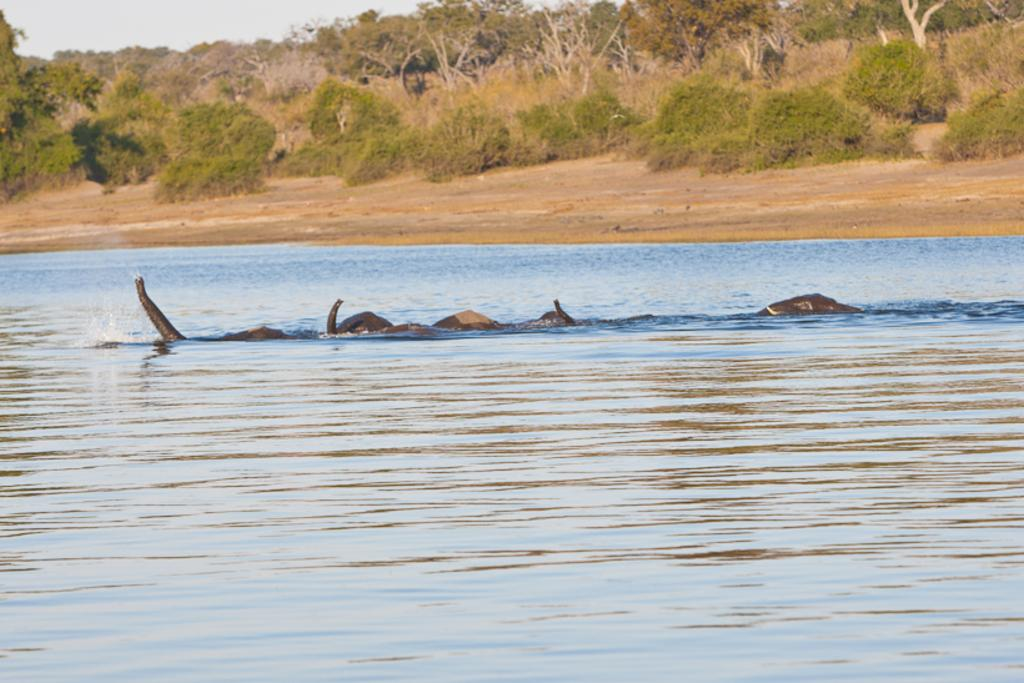What type of animals can be seen in the image? There are animals in the water in the image. What can be seen in the background of the image? There are trees, the sky, and bushes in the background of the image. What is visible at the bottom of the image? The ground is visible in the image. What is the answer to the question that the animals are asking in the image? There is no indication in the image that the animals are asking any questions, so it's not possible to determine an answer. 